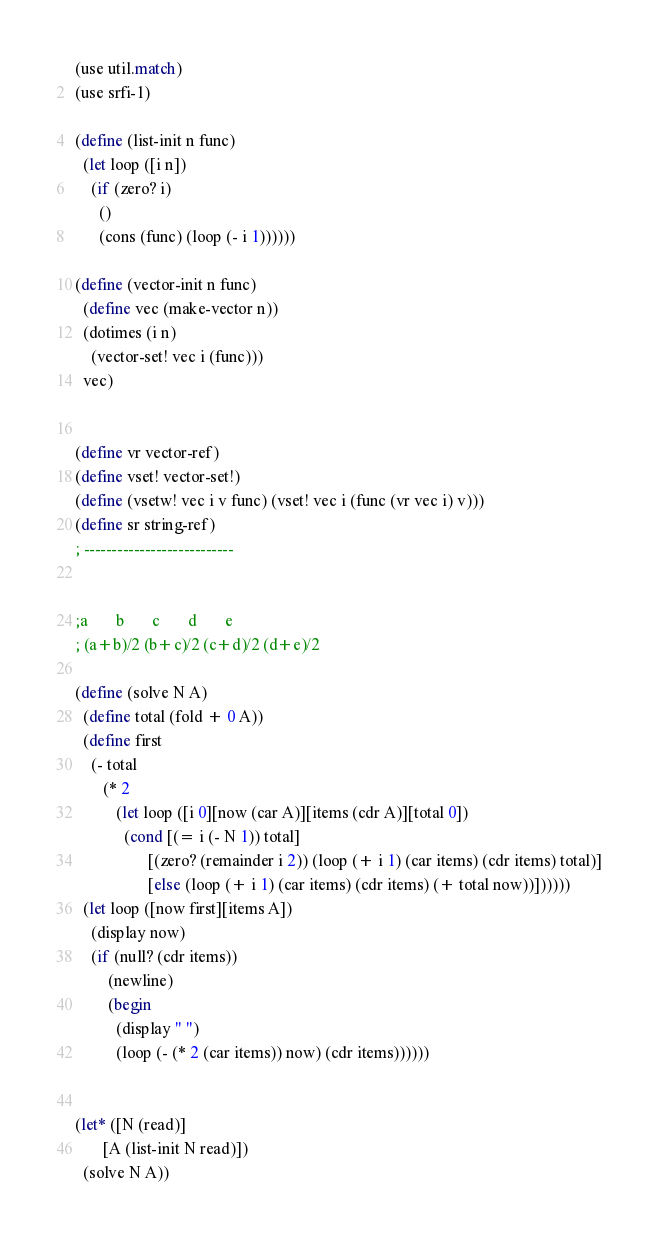Convert code to text. <code><loc_0><loc_0><loc_500><loc_500><_Scheme_>(use util.match)
(use srfi-1)

(define (list-init n func)
  (let loop ([i n])
    (if (zero? i)
      ()
      (cons (func) (loop (- i 1))))))

(define (vector-init n func)
  (define vec (make-vector n))
  (dotimes (i n)
    (vector-set! vec i (func)))
  vec)


(define vr vector-ref)
(define vset! vector-set!)
(define (vsetw! vec i v func) (vset! vec i (func (vr vec i) v)))
(define sr string-ref)
; ---------------------------


;a       b       c       d       e
; (a+b)/2 (b+c)/2 (c+d)/2 (d+e)/2

(define (solve N A)
  (define total (fold + 0 A))
  (define first
    (- total
       (* 2
          (let loop ([i 0][now (car A)][items (cdr A)][total 0])
            (cond [(= i (- N 1)) total]
                  [(zero? (remainder i 2)) (loop (+ i 1) (car items) (cdr items) total)]
                  [else (loop (+ i 1) (car items) (cdr items) (+ total now))])))))
  (let loop ([now first][items A])
    (display now)
    (if (null? (cdr items))
        (newline)
        (begin 
          (display " ")
          (loop (- (* 2 (car items)) now) (cdr items))))))


(let* ([N (read)]
       [A (list-init N read)])
  (solve N A))</code> 